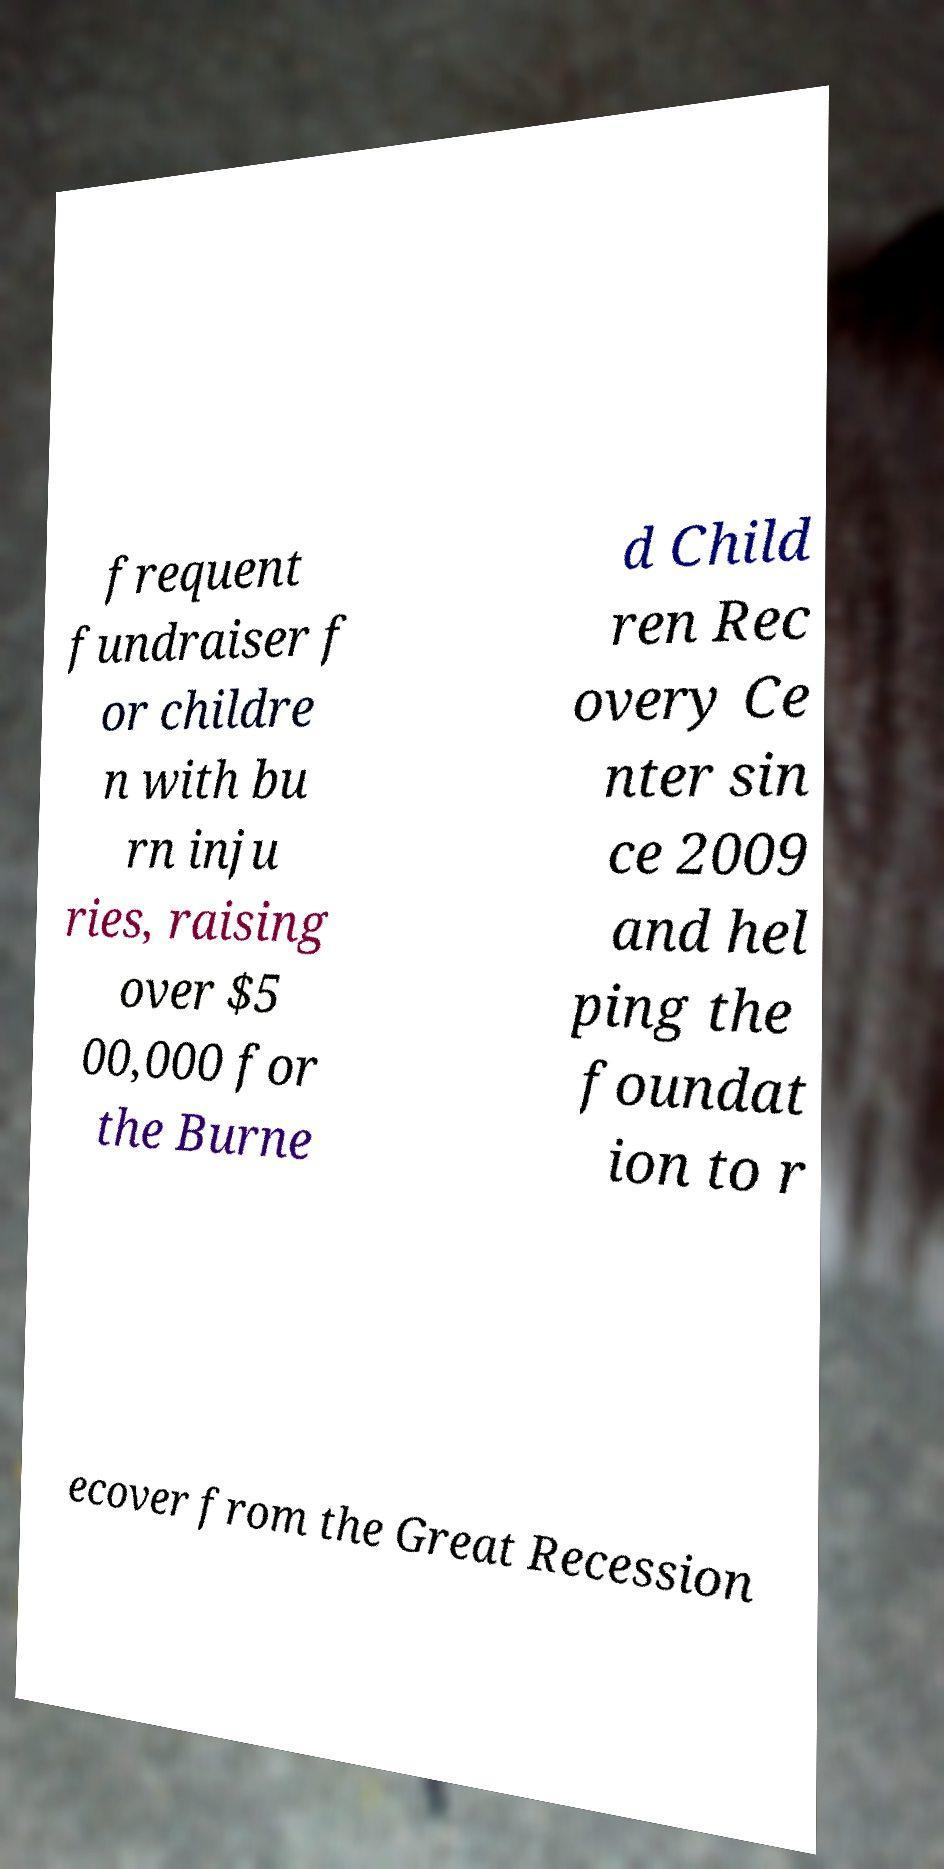Can you read and provide the text displayed in the image?This photo seems to have some interesting text. Can you extract and type it out for me? frequent fundraiser f or childre n with bu rn inju ries, raising over $5 00,000 for the Burne d Child ren Rec overy Ce nter sin ce 2009 and hel ping the foundat ion to r ecover from the Great Recession 